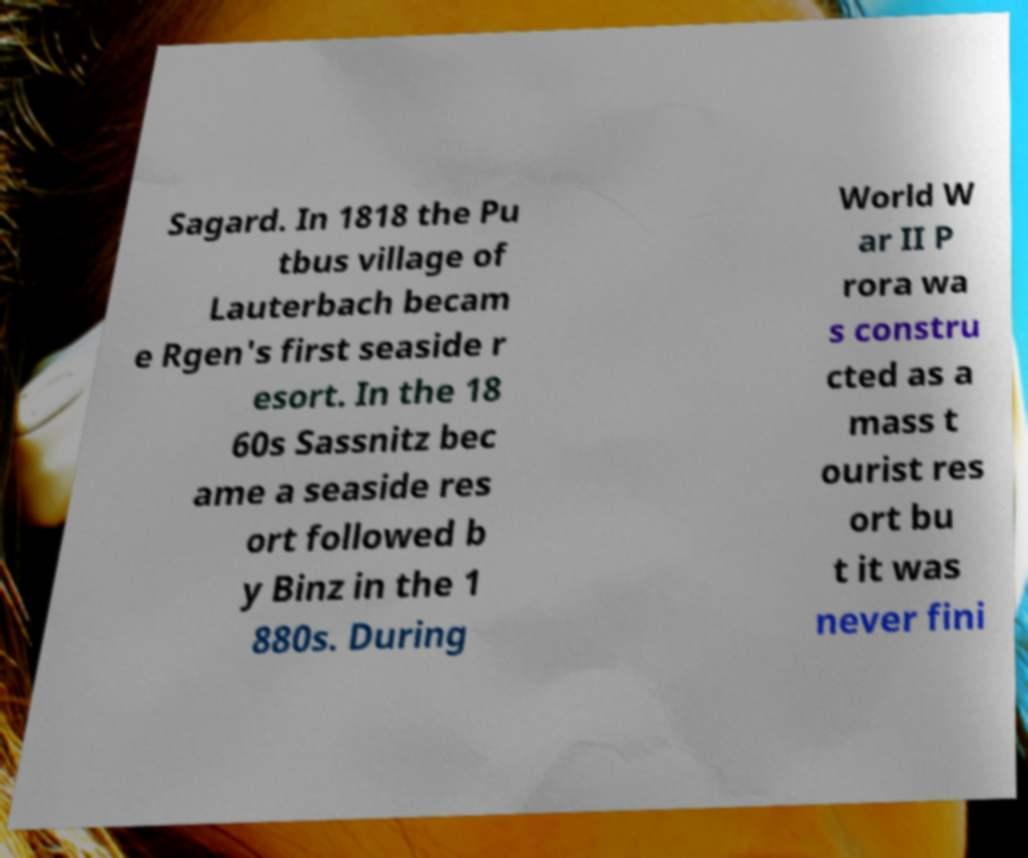Please identify and transcribe the text found in this image. Sagard. In 1818 the Pu tbus village of Lauterbach becam e Rgen's first seaside r esort. In the 18 60s Sassnitz bec ame a seaside res ort followed b y Binz in the 1 880s. During World W ar II P rora wa s constru cted as a mass t ourist res ort bu t it was never fini 